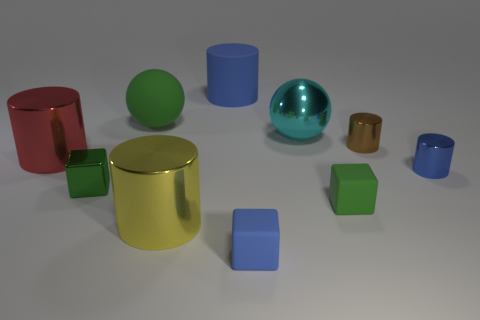Subtract all tiny cylinders. How many cylinders are left? 3 Subtract all brown cylinders. How many cylinders are left? 4 Subtract 1 cylinders. How many cylinders are left? 4 Add 4 big things. How many big things are left? 9 Add 9 big yellow balls. How many big yellow balls exist? 9 Subtract 0 blue spheres. How many objects are left? 10 Subtract all spheres. How many objects are left? 8 Subtract all gray balls. Subtract all yellow blocks. How many balls are left? 2 Subtract all gray cylinders. How many yellow spheres are left? 0 Subtract all tiny cylinders. Subtract all red shiny cylinders. How many objects are left? 7 